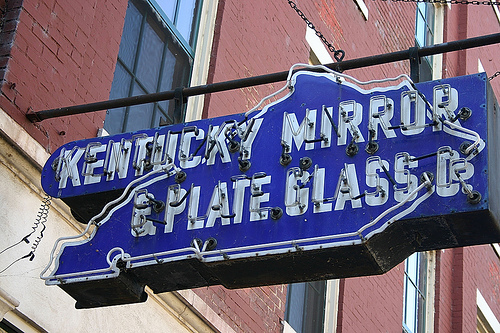<image>
Is there a bricks above the chain? Yes. The bricks is positioned above the chain in the vertical space, higher up in the scene. 